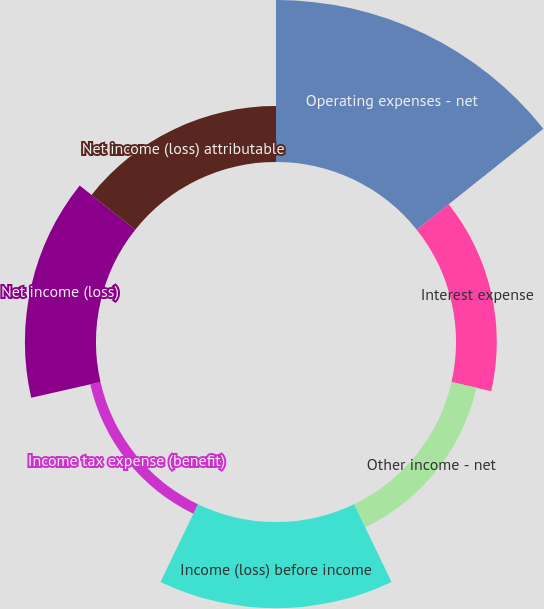Convert chart to OTSL. <chart><loc_0><loc_0><loc_500><loc_500><pie_chart><fcel>Operating expenses - net<fcel>Interest expense<fcel>Other income - net<fcel>Income (loss) before income<fcel>Income tax expense (benefit)<fcel>Net income (loss)<fcel>Net income (loss) attributable<nl><fcel>35.82%<fcel>9.02%<fcel>5.67%<fcel>19.07%<fcel>2.32%<fcel>15.72%<fcel>12.37%<nl></chart> 